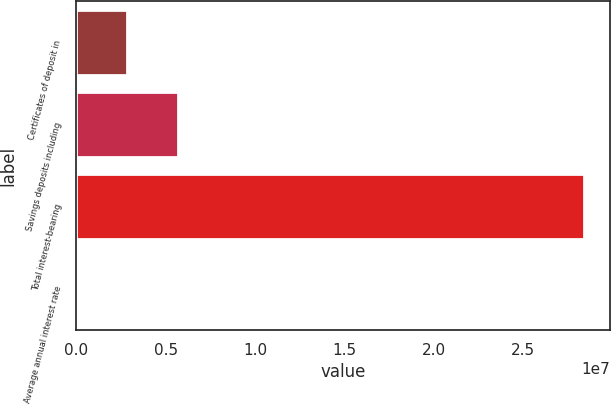Convert chart. <chart><loc_0><loc_0><loc_500><loc_500><bar_chart><fcel>Certificates of deposit in<fcel>Savings deposits including<fcel>Total interest-bearing<fcel>Average annual interest rate<nl><fcel>2.84522e+06<fcel>5.69043e+06<fcel>2.84521e+07<fcel>4.67<nl></chart> 